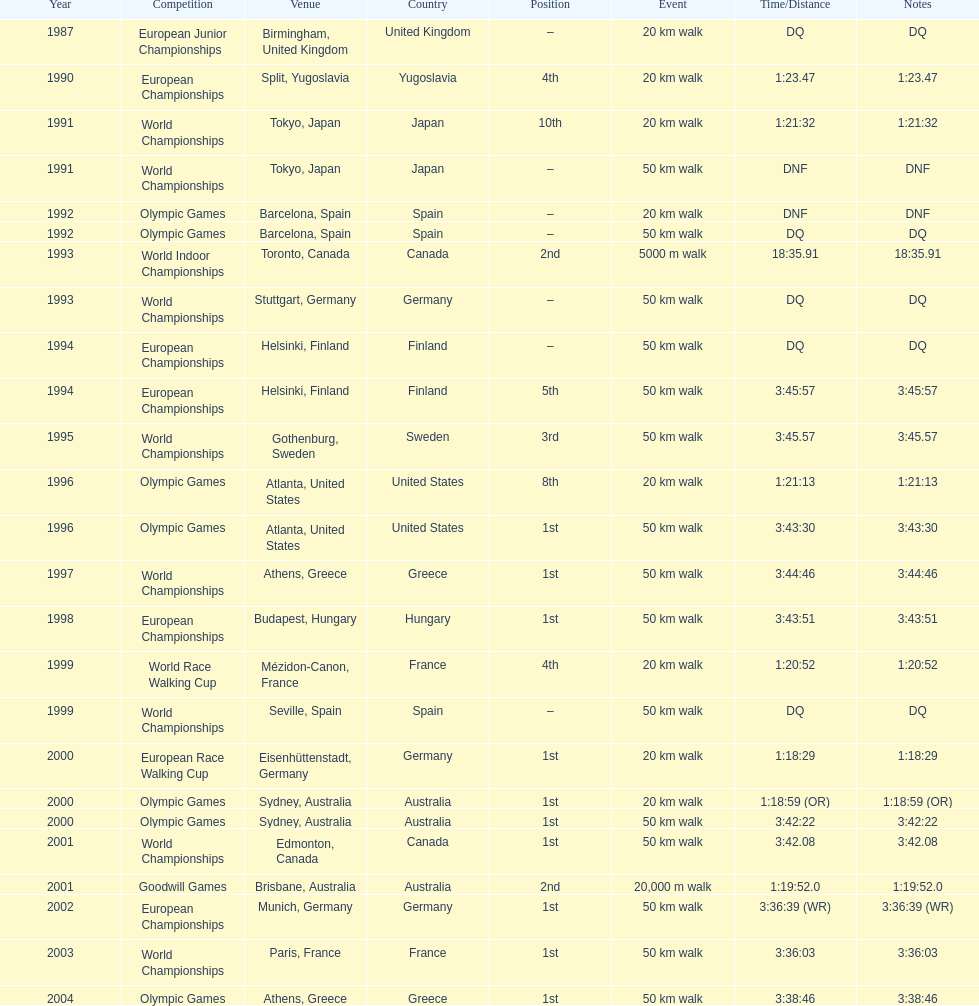In what year was korzeniowski's last competition? 2004. 